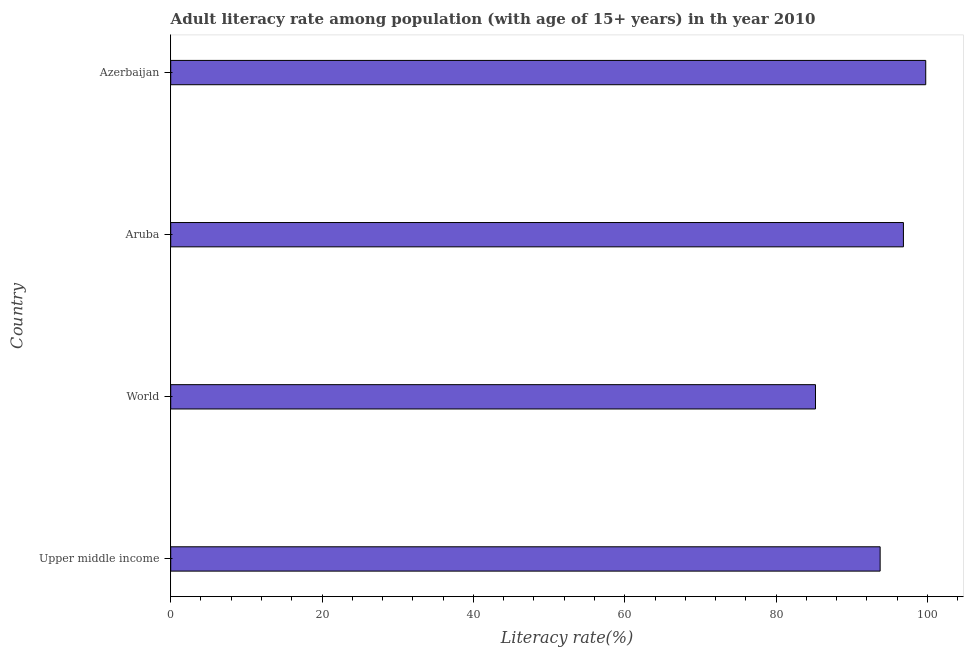Does the graph contain any zero values?
Keep it short and to the point. No. Does the graph contain grids?
Provide a short and direct response. No. What is the title of the graph?
Provide a short and direct response. Adult literacy rate among population (with age of 15+ years) in th year 2010. What is the label or title of the X-axis?
Your response must be concise. Literacy rate(%). What is the adult literacy rate in Aruba?
Offer a terse response. 96.82. Across all countries, what is the maximum adult literacy rate?
Keep it short and to the point. 99.77. Across all countries, what is the minimum adult literacy rate?
Give a very brief answer. 85.2. In which country was the adult literacy rate maximum?
Your answer should be compact. Azerbaijan. What is the sum of the adult literacy rate?
Make the answer very short. 375.54. What is the difference between the adult literacy rate in Upper middle income and World?
Your answer should be very brief. 8.54. What is the average adult literacy rate per country?
Provide a succinct answer. 93.89. What is the median adult literacy rate?
Your response must be concise. 95.28. What is the ratio of the adult literacy rate in Upper middle income to that in World?
Make the answer very short. 1.1. Is the difference between the adult literacy rate in Aruba and World greater than the difference between any two countries?
Your answer should be compact. No. What is the difference between the highest and the second highest adult literacy rate?
Give a very brief answer. 2.95. What is the difference between the highest and the lowest adult literacy rate?
Your answer should be compact. 14.57. How many bars are there?
Your answer should be compact. 4. What is the difference between two consecutive major ticks on the X-axis?
Provide a succinct answer. 20. What is the Literacy rate(%) in Upper middle income?
Make the answer very short. 93.75. What is the Literacy rate(%) in World?
Your answer should be very brief. 85.2. What is the Literacy rate(%) of Aruba?
Your answer should be very brief. 96.82. What is the Literacy rate(%) of Azerbaijan?
Your response must be concise. 99.77. What is the difference between the Literacy rate(%) in Upper middle income and World?
Offer a terse response. 8.55. What is the difference between the Literacy rate(%) in Upper middle income and Aruba?
Your answer should be compact. -3.08. What is the difference between the Literacy rate(%) in Upper middle income and Azerbaijan?
Your answer should be compact. -6.03. What is the difference between the Literacy rate(%) in World and Aruba?
Offer a terse response. -11.62. What is the difference between the Literacy rate(%) in World and Azerbaijan?
Provide a succinct answer. -14.57. What is the difference between the Literacy rate(%) in Aruba and Azerbaijan?
Offer a terse response. -2.95. What is the ratio of the Literacy rate(%) in Upper middle income to that in World?
Ensure brevity in your answer.  1.1. What is the ratio of the Literacy rate(%) in Upper middle income to that in Aruba?
Give a very brief answer. 0.97. What is the ratio of the Literacy rate(%) in Upper middle income to that in Azerbaijan?
Provide a short and direct response. 0.94. What is the ratio of the Literacy rate(%) in World to that in Azerbaijan?
Your response must be concise. 0.85. What is the ratio of the Literacy rate(%) in Aruba to that in Azerbaijan?
Make the answer very short. 0.97. 